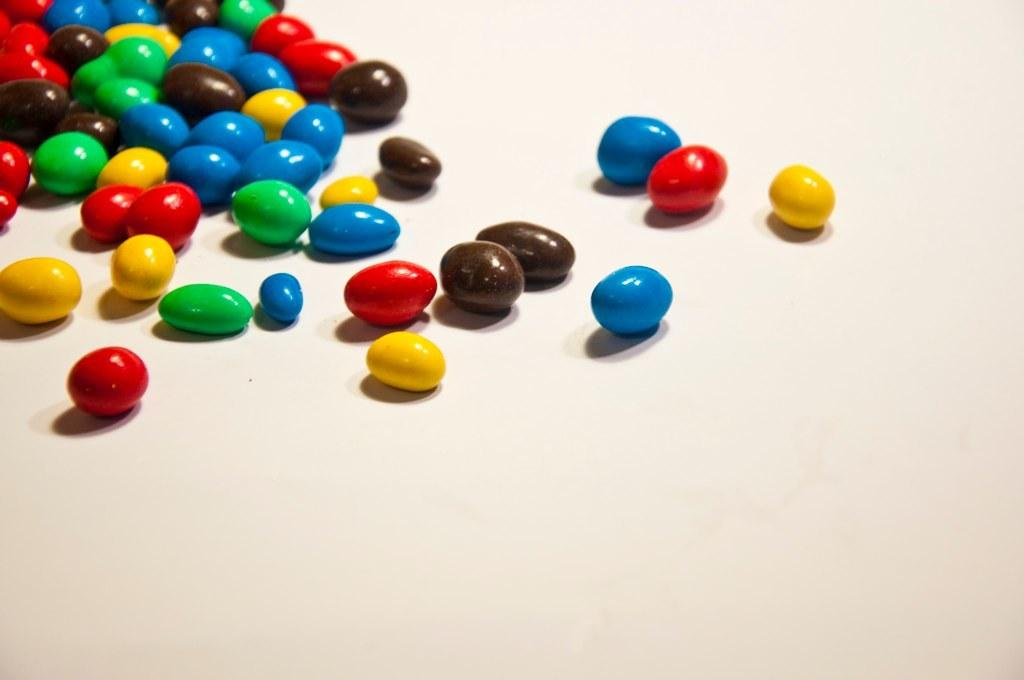What is present on the table in the image? There are germs on the table in the image. What type of star can be seen in the image? There is no star present in the image; it only mentions germs on the table. What tool is being used to dig in the image? There is no digging tool or activity depicted in the image; it only mentions germs on the table. 